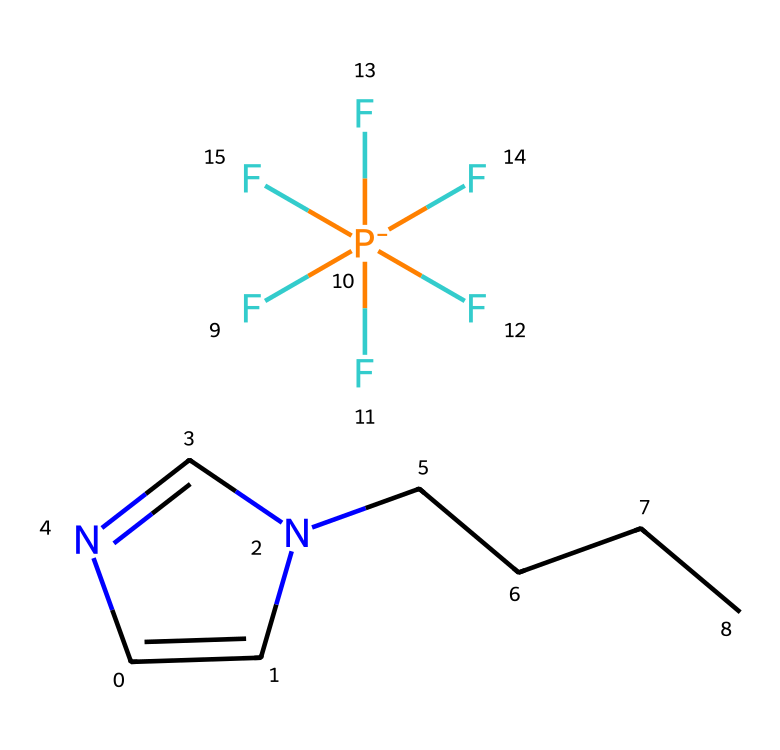What is the molecular formula of this ionic liquid? By examining the structure and counting the number of each type of atom present, we can deduce that there are 12 carbon (C) atoms, 15 hydrogen (H) atoms, 1 nitrogen (N) atom, 1 phosphorus (P) atom, and 6 fluorine (F) atoms. Therefore, the molecular formula is C12H15F6N.
Answer: C12H15F6N How many nitrogen atoms are present in this ionic liquid? The chemical structure shows one nitrogen atom (N) included in the cyclic part of the molecule. Therefore, we can count that there is a total of 1 nitrogen atom present.
Answer: 1 What type of bonding is prevalent in this ionic liquid? Ionic liquids typically have ionic bonding due to the presence of charged ions in their structure. Here, the phosphorus atom is positively charged, and the fluoride groups provide the negative charge, indicating ionic bonding.
Answer: ionic bonding Which part of the structure indicates it is based on a nitrogen-containing heterocycle? The cyclic structure containing the nitrogen atom (C1=CN(C=N1)) indicates that it is a nitrogen-containing heterocycle. This structure is crucial for defining its properties as an ionic liquid.
Answer: nitrogen-containing heterocycle What role does the fluoride ion play in this ionic liquid? The fluoride ions contribute to the ionic character of the liquid and affect its solubility and stability in various solvents, making it efficient as a green solvent. They help in stabilizing the ionic structure.
Answer: stability How many total fluorine atoms are present in this ionic liquid? In the given ionic liquid structure, there are six bonded fluorine atoms connected to the phosphorus atom. Thus, the total number of fluorine atoms is 6.
Answer: 6 Is this ionic liquid considered environmentally friendly? Yes, ionic liquids are often designed to be less volatile and more thermally stable compared to traditional solvents, which makes them more environmentally friendly, though specific environmental impacts depend on individual ionic liquid compositions.
Answer: environmentally friendly 